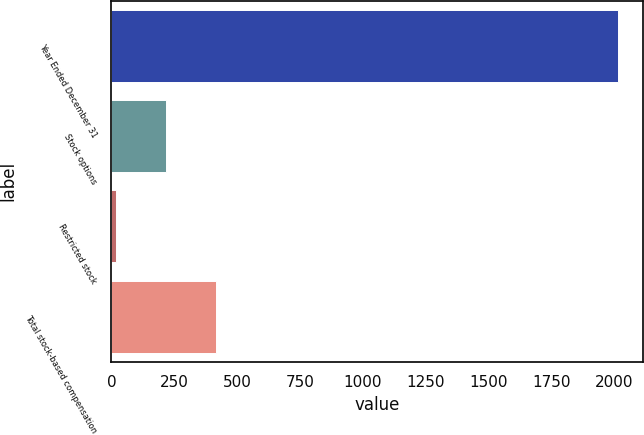Convert chart to OTSL. <chart><loc_0><loc_0><loc_500><loc_500><bar_chart><fcel>Year Ended December 31<fcel>Stock options<fcel>Restricted stock<fcel>Total stock-based compensation<nl><fcel>2012<fcel>216.5<fcel>17<fcel>416<nl></chart> 